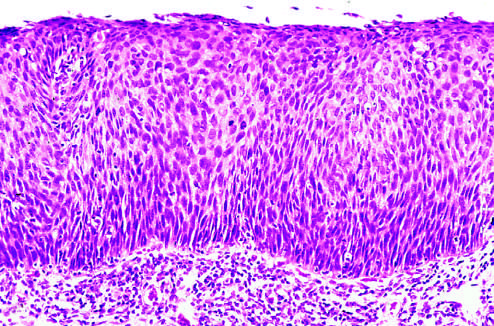do interstitial fibrosis and tubular atrophy show that the entire thickness of the epithelium is replaced by atypical dysplastic cells?
Answer the question using a single word or phrase. No 